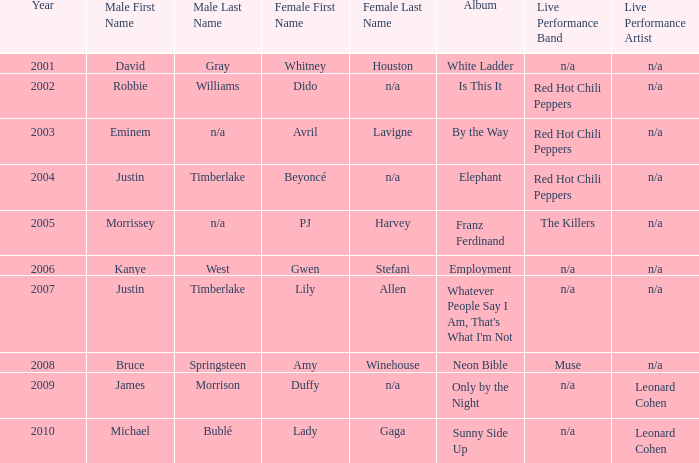In 2004, which man was linked with dido? Robbie Williams. 